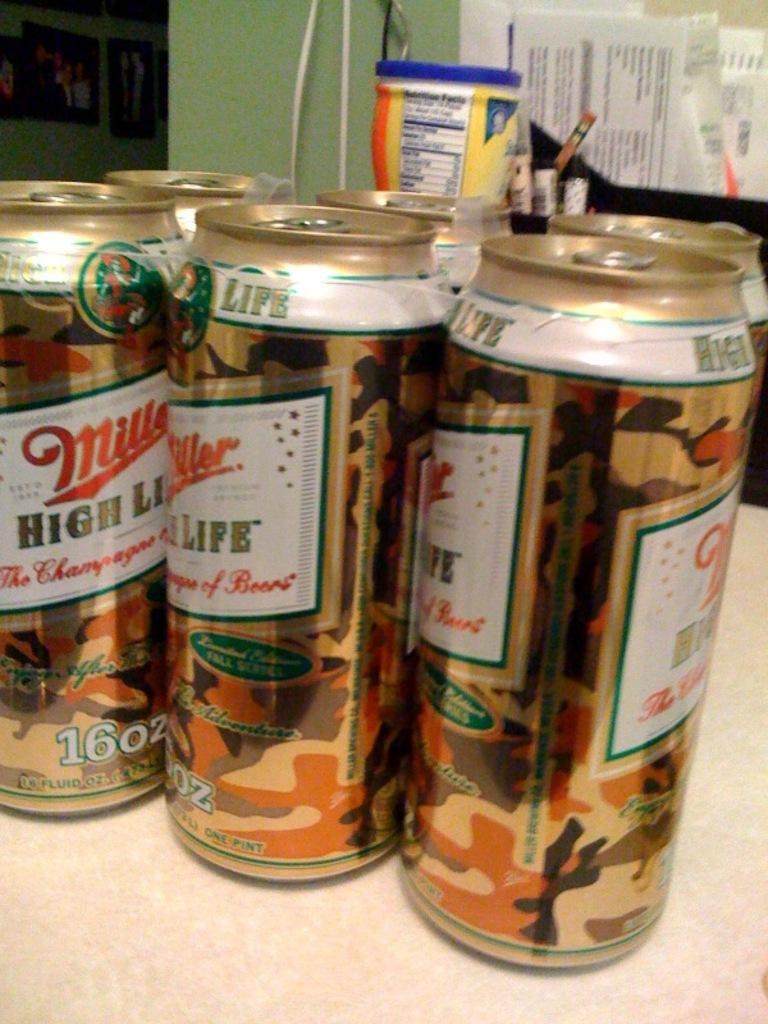<image>
Give a short and clear explanation of the subsequent image. Six cans of Miler High Life sit on a table. 